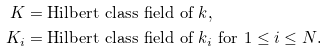Convert formula to latex. <formula><loc_0><loc_0><loc_500><loc_500>K & = \text {Hilbert class field of $k$,} \\ K _ { i } & = \text {Hilbert class field of $k_{i}$ for $1\leq i\leq N$.}</formula> 